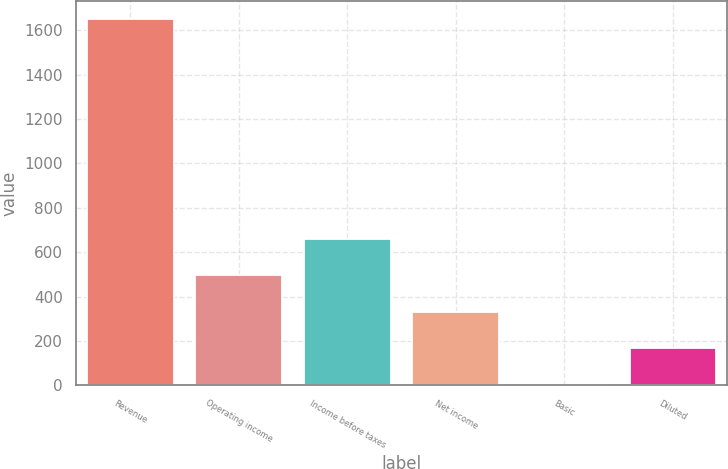Convert chart. <chart><loc_0><loc_0><loc_500><loc_500><bar_chart><fcel>Revenue<fcel>Operating income<fcel>Income before taxes<fcel>Net income<fcel>Basic<fcel>Diluted<nl><fcel>1650.8<fcel>496.26<fcel>661.2<fcel>331.32<fcel>1.44<fcel>166.38<nl></chart> 